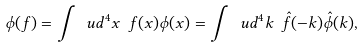<formula> <loc_0><loc_0><loc_500><loc_500>\phi ( f ) = \int \ u d ^ { 4 } x \ f ( x ) \phi ( x ) = \int \ u d ^ { 4 } k \ \hat { f } ( - k ) \hat { \phi } ( k ) ,</formula> 